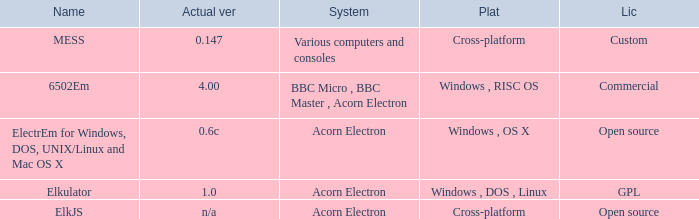What is the system called that is named ELKJS? Acorn Electron. Can you parse all the data within this table? {'header': ['Name', 'Actual ver', 'System', 'Plat', 'Lic'], 'rows': [['MESS', '0.147', 'Various computers and consoles', 'Cross-platform', 'Custom'], ['6502Em', '4.00', 'BBC Micro , BBC Master , Acorn Electron', 'Windows , RISC OS', 'Commercial'], ['ElectrEm for Windows, DOS, UNIX/Linux and Mac OS X', '0.6c', 'Acorn Electron', 'Windows , OS X', 'Open source'], ['Elkulator', '1.0', 'Acorn Electron', 'Windows , DOS , Linux', 'GPL'], ['ElkJS', 'n/a', 'Acorn Electron', 'Cross-platform', 'Open source']]} 